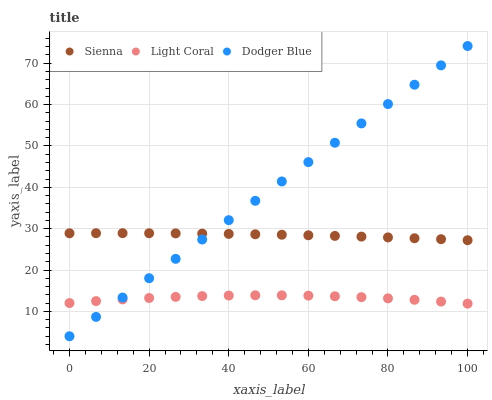Does Light Coral have the minimum area under the curve?
Answer yes or no. Yes. Does Dodger Blue have the maximum area under the curve?
Answer yes or no. Yes. Does Dodger Blue have the minimum area under the curve?
Answer yes or no. No. Does Light Coral have the maximum area under the curve?
Answer yes or no. No. Is Dodger Blue the smoothest?
Answer yes or no. Yes. Is Light Coral the roughest?
Answer yes or no. Yes. Is Light Coral the smoothest?
Answer yes or no. No. Is Dodger Blue the roughest?
Answer yes or no. No. Does Dodger Blue have the lowest value?
Answer yes or no. Yes. Does Light Coral have the lowest value?
Answer yes or no. No. Does Dodger Blue have the highest value?
Answer yes or no. Yes. Does Light Coral have the highest value?
Answer yes or no. No. Is Light Coral less than Sienna?
Answer yes or no. Yes. Is Sienna greater than Light Coral?
Answer yes or no. Yes. Does Sienna intersect Dodger Blue?
Answer yes or no. Yes. Is Sienna less than Dodger Blue?
Answer yes or no. No. Is Sienna greater than Dodger Blue?
Answer yes or no. No. Does Light Coral intersect Sienna?
Answer yes or no. No. 